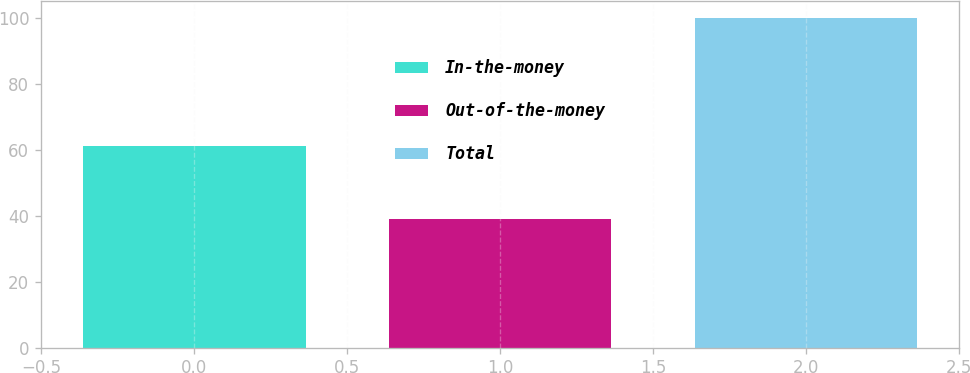Convert chart to OTSL. <chart><loc_0><loc_0><loc_500><loc_500><bar_chart><fcel>In-the-money<fcel>Out-of-the-money<fcel>Total<nl><fcel>61<fcel>39<fcel>100<nl></chart> 